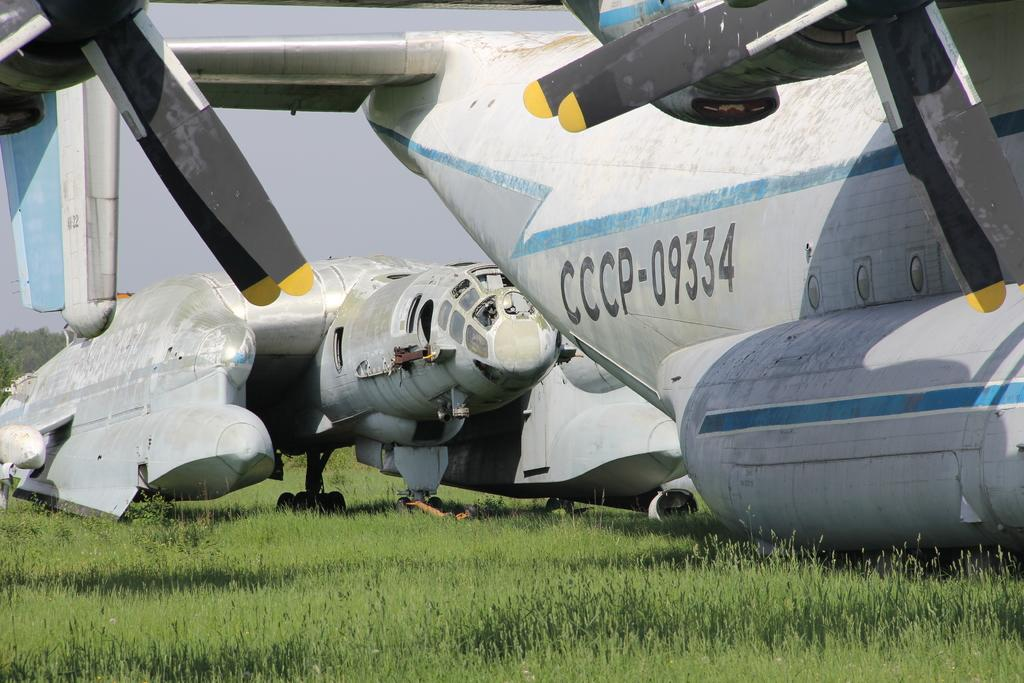<image>
Provide a brief description of the given image. An airplane on the ground is labeled with CCCP-09334. 